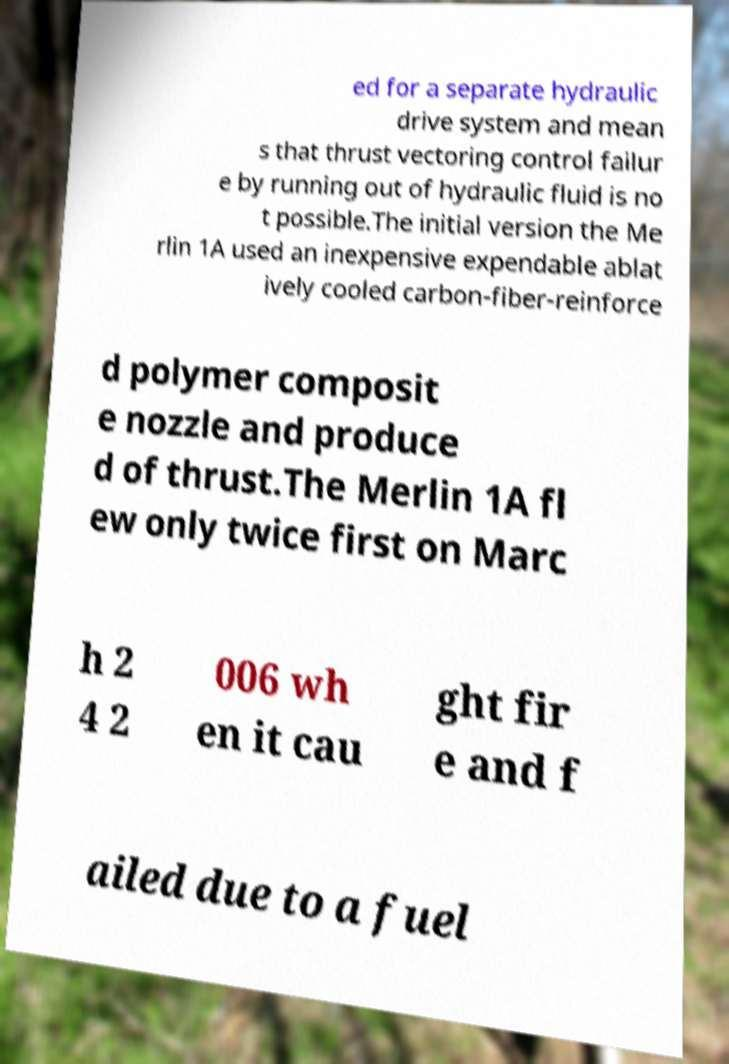Please read and relay the text visible in this image. What does it say? ed for a separate hydraulic drive system and mean s that thrust vectoring control failur e by running out of hydraulic fluid is no t possible.The initial version the Me rlin 1A used an inexpensive expendable ablat ively cooled carbon-fiber-reinforce d polymer composit e nozzle and produce d of thrust.The Merlin 1A fl ew only twice first on Marc h 2 4 2 006 wh en it cau ght fir e and f ailed due to a fuel 